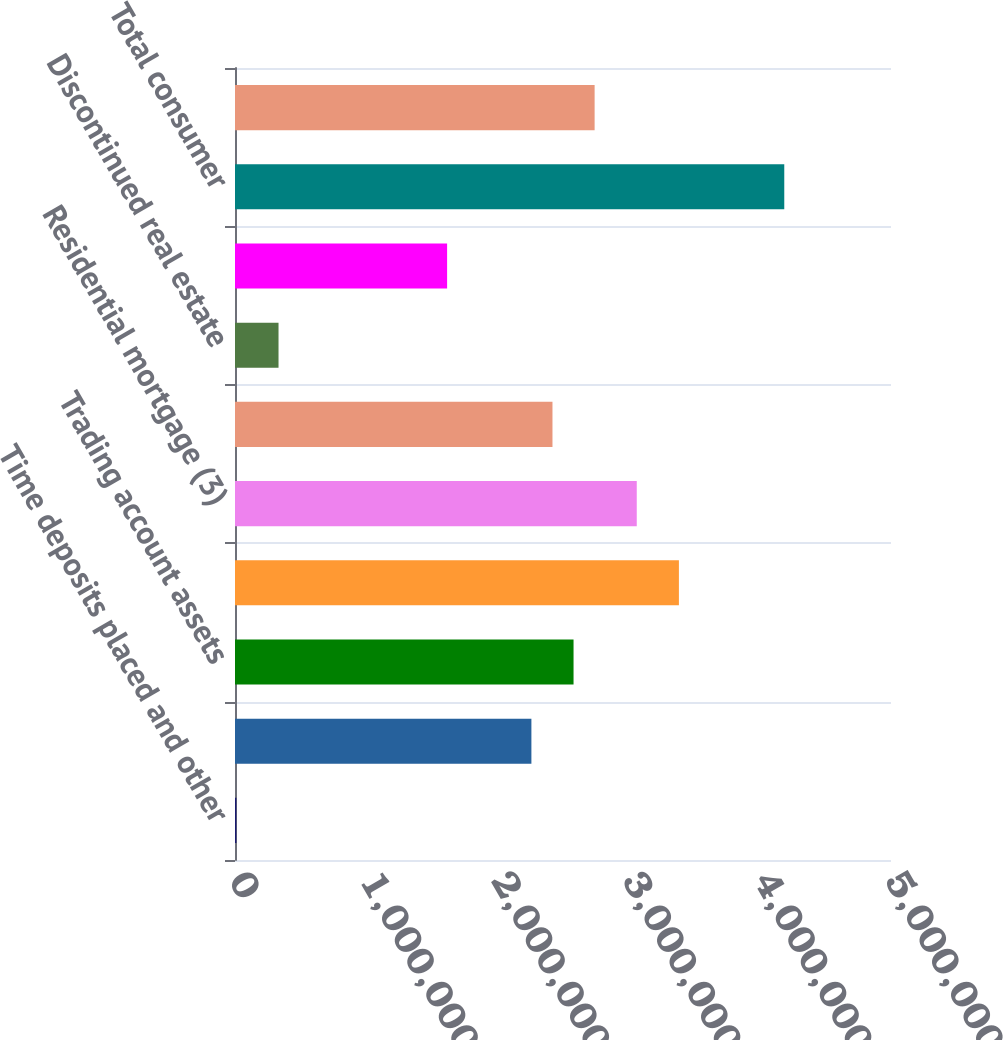<chart> <loc_0><loc_0><loc_500><loc_500><bar_chart><fcel>Time deposits placed and other<fcel>Federal funds sold and<fcel>Trading account assets<fcel>Debt securities (1)<fcel>Residential mortgage (3)<fcel>Home equity<fcel>Discontinued real estate<fcel>Credit card - domestic<fcel>Total consumer<fcel>Commercial - domestic<nl><fcel>10511<fcel>2.25914e+06<fcel>2.58037e+06<fcel>3.38345e+06<fcel>3.06222e+06<fcel>2.41975e+06<fcel>331743<fcel>1.61667e+06<fcel>4.18653e+06<fcel>2.74099e+06<nl></chart> 